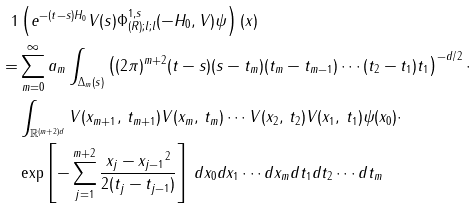Convert formula to latex. <formula><loc_0><loc_0><loc_500><loc_500>{ 1 } & \left ( e ^ { - ( t - s ) H _ { 0 } } V ( s ) \Phi _ { ( R ) ; l ; l } ^ { 1 , s } ( - H _ { 0 } , V ) \psi \right ) ( x ) \\ = & \sum _ { m = 0 } ^ { \infty } a _ { m } \int _ { \Delta _ { m } ( s ) } \left ( ( 2 \pi ) ^ { m + 2 } ( t - s ) ( s - t _ { m } ) ( t _ { m } - t _ { m - 1 } ) \cdots ( t _ { 2 } - t _ { 1 } ) t _ { 1 } \right ) ^ { - d / 2 } \cdot \\ & \int _ { \mathbb { R } ^ { ( m + 2 ) d } } V ( x _ { m + 1 } , \, t _ { m + 1 } ) V ( x _ { m } , \, t _ { m } ) \cdots V ( x _ { 2 } , \, t _ { 2 } ) V ( x _ { 1 } , \, t _ { 1 } ) \psi ( x _ { 0 } ) \cdot \\ & \exp \left [ - \sum _ { j = 1 } ^ { m + 2 } \frac { \| x _ { j } - x _ { j - 1 } \| ^ { 2 } } { 2 ( t _ { j } - t _ { j - 1 } ) } \right ] \, d x _ { 0 } d x _ { 1 } \cdots d x _ { m } d t _ { 1 } d t _ { 2 } \cdots d t _ { m }</formula> 